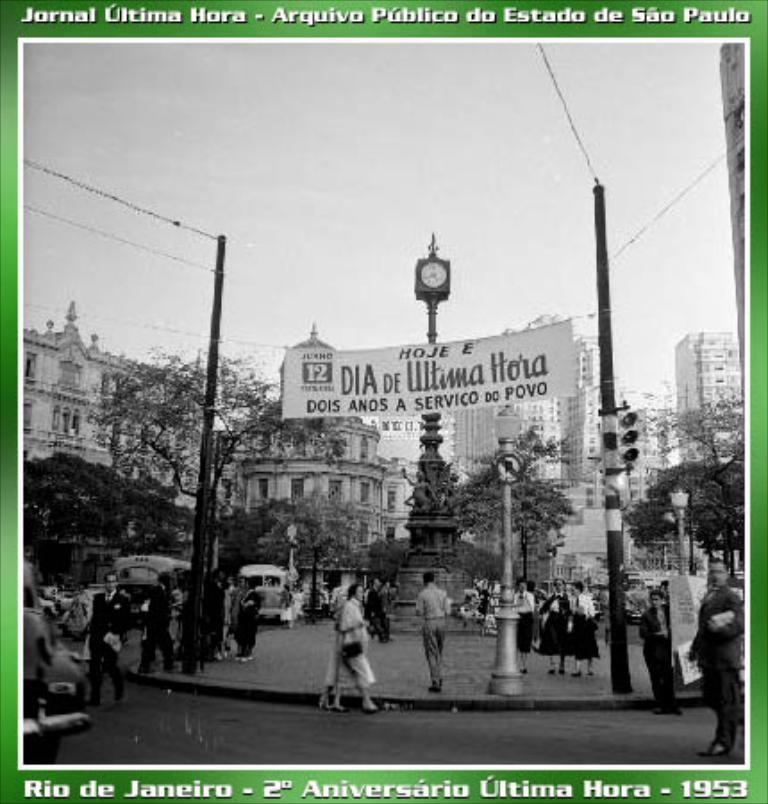In one or two sentences, can you explain what this image depicts? It is an edited image, in the picture there are a lot of people moving around the road and at the center of the road there is a tall pole with clock and some sculptures, around that pole there are many buildings and trees, there are two poles in front of that sculpture and many wires are attached to those poles. 